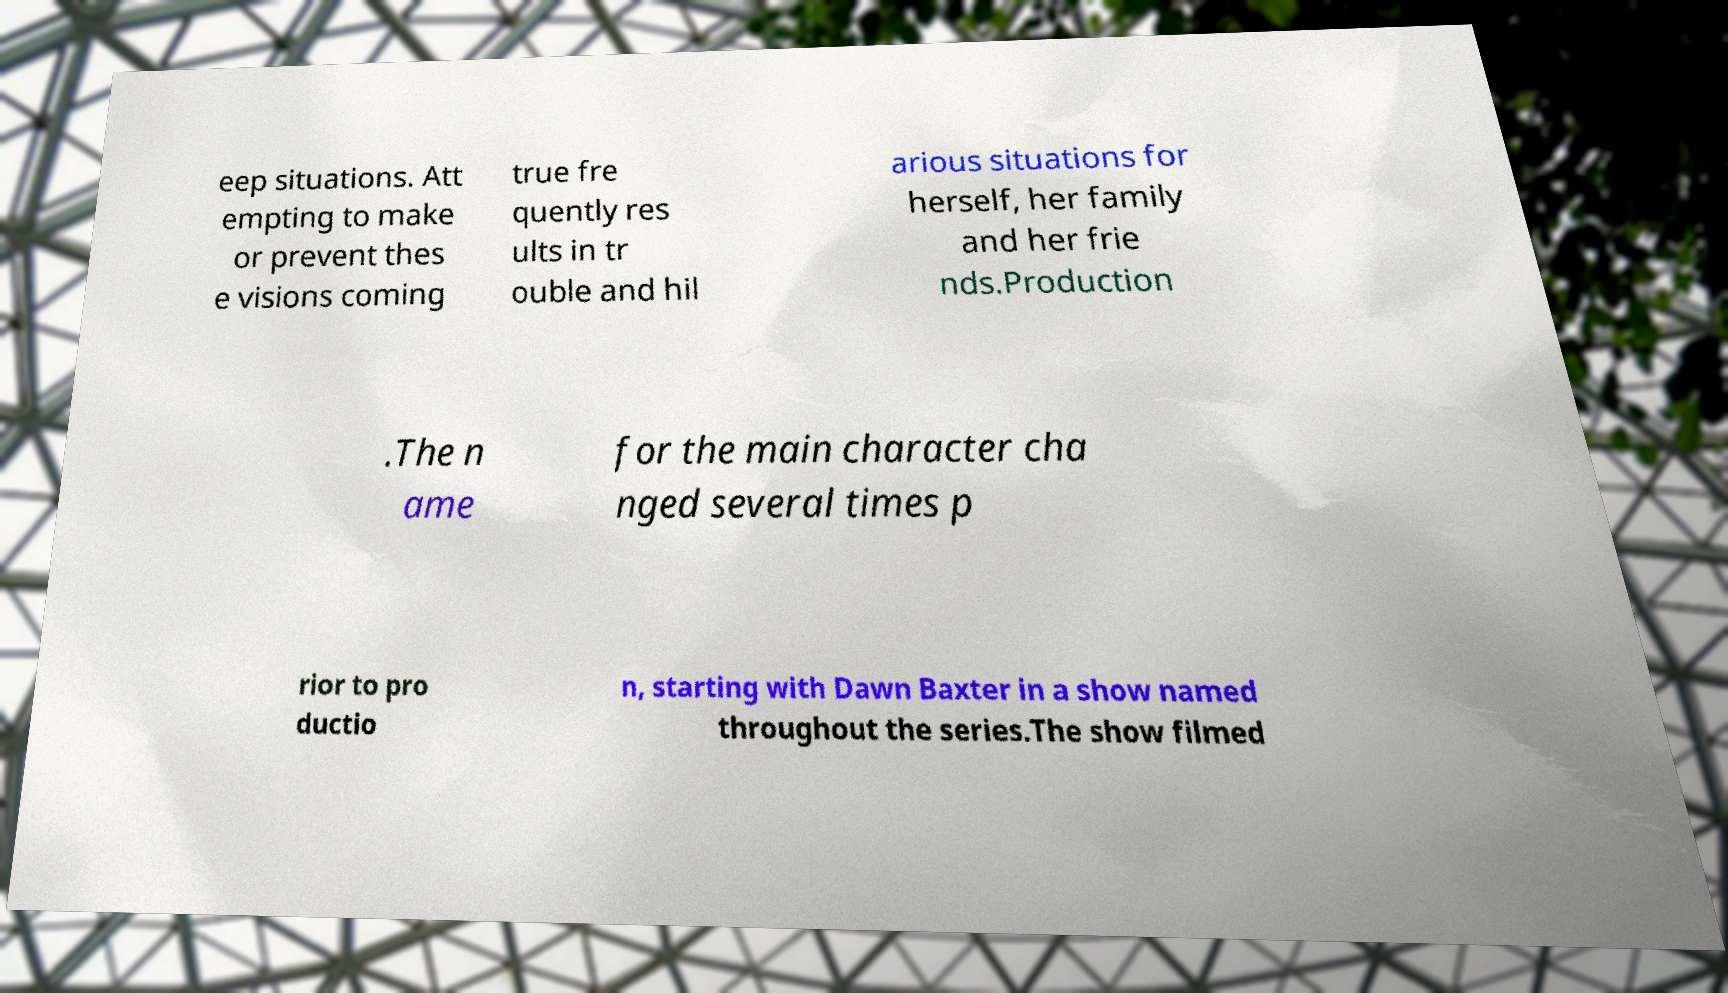There's text embedded in this image that I need extracted. Can you transcribe it verbatim? eep situations. Att empting to make or prevent thes e visions coming true fre quently res ults in tr ouble and hil arious situations for herself, her family and her frie nds.Production .The n ame for the main character cha nged several times p rior to pro ductio n, starting with Dawn Baxter in a show named throughout the series.The show filmed 